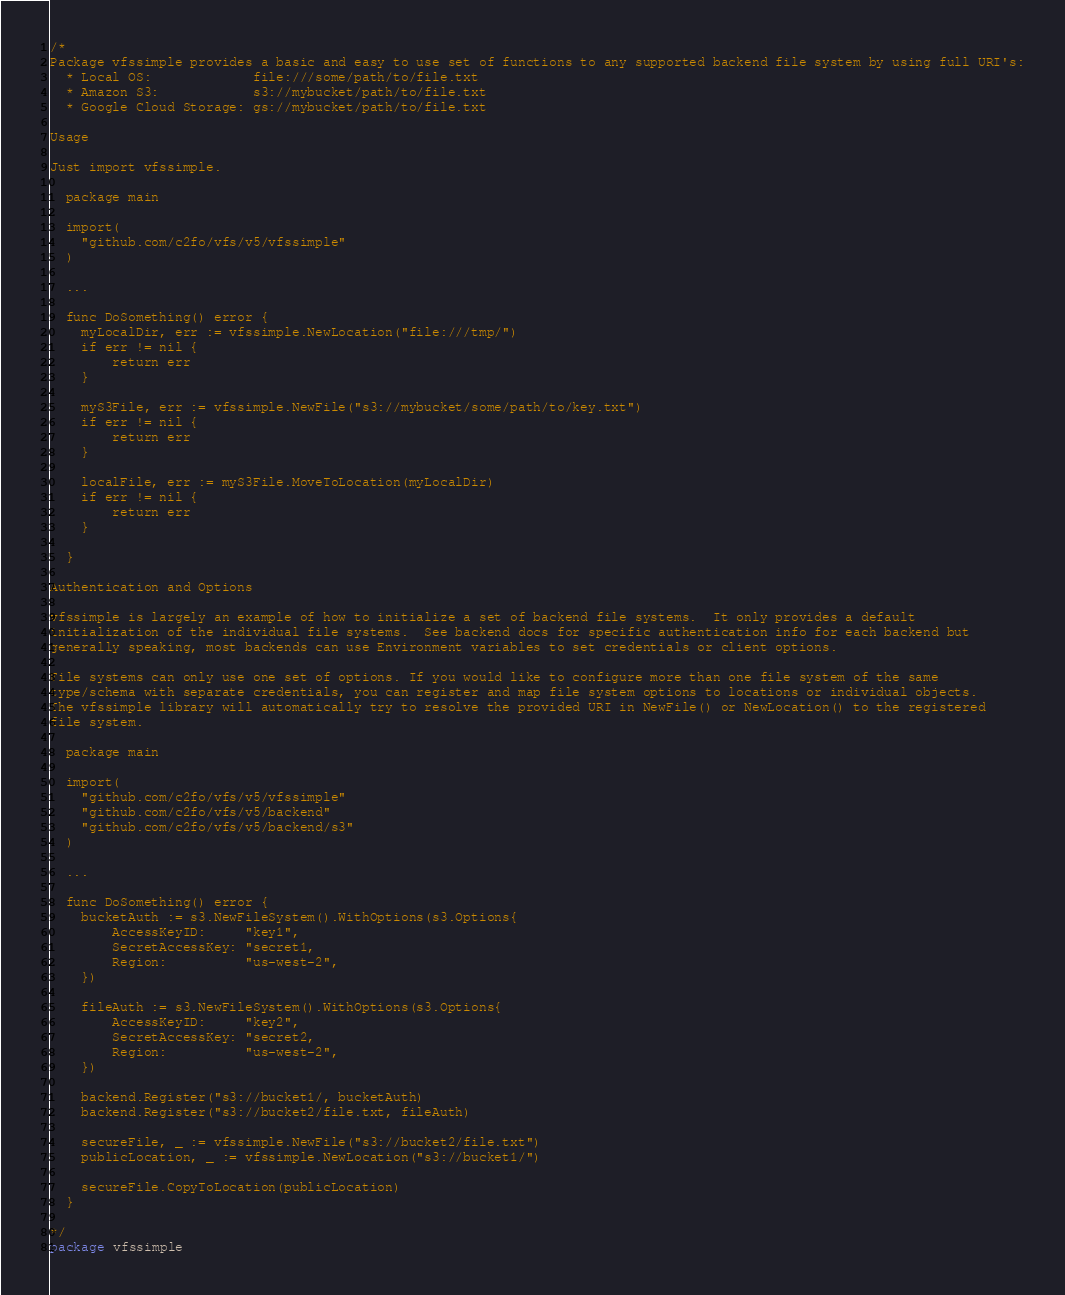Convert code to text. <code><loc_0><loc_0><loc_500><loc_500><_Go_>/*
Package vfssimple provides a basic and easy to use set of functions to any supported backend file system by using full URI's:
  * Local OS:             file:///some/path/to/file.txt
  * Amazon S3:            s3://mybucket/path/to/file.txt
  * Google Cloud Storage: gs://mybucket/path/to/file.txt

Usage

Just import vfssimple.

  package main

  import(
	"github.com/c2fo/vfs/v5/vfssimple"
  )

  ...

  func DoSomething() error {
    myLocalDir, err := vfssimple.NewLocation("file:///tmp/")
    if err != nil {
        return err
    }

    myS3File, err := vfssimple.NewFile("s3://mybucket/some/path/to/key.txt")
    if err != nil {
        return err
    }

    localFile, err := myS3File.MoveToLocation(myLocalDir)
    if err != nil {
        return err
    }

  }

Authentication and Options

vfssimple is largely an example of how to initialize a set of backend file systems.  It only provides a default
initialization of the individual file systems.  See backend docs for specific authentication info for each backend but
generally speaking, most backends can use Environment variables to set credentials or client options.

File systems can only use one set of options. If you would like to configure more than one file system of the same
type/schema with separate credentials, you can register and map file system options to locations or individual objects.
The vfssimple library will automatically try to resolve the provided URI in NewFile() or NewLocation() to the registered
file system.

  package main

  import(
	"github.com/c2fo/vfs/v5/vfssimple"
	"github.com/c2fo/vfs/v5/backend"
	"github.com/c2fo/vfs/v5/backend/s3"
  )

  ...

  func DoSomething() error {
	bucketAuth := s3.NewFileSystem().WithOptions(s3.Options{
		AccessKeyID:     "key1",
		SecretAccessKey: "secret1,
		Region:          "us-west-2",
	})

	fileAuth := s3.NewFileSystem().WithOptions(s3.Options{
		AccessKeyID:     "key2",
		SecretAccessKey: "secret2,
		Region:          "us-west-2",
	})

	backend.Register("s3://bucket1/, bucketAuth)
	backend.Register("s3://bucket2/file.txt, fileAuth)

	secureFile, _ := vfssimple.NewFile("s3://bucket2/file.txt")
	publicLocation, _ := vfssimple.NewLocation("s3://bucket1/")

	secureFile.CopyToLocation(publicLocation)
  }

*/
package vfssimple
</code> 